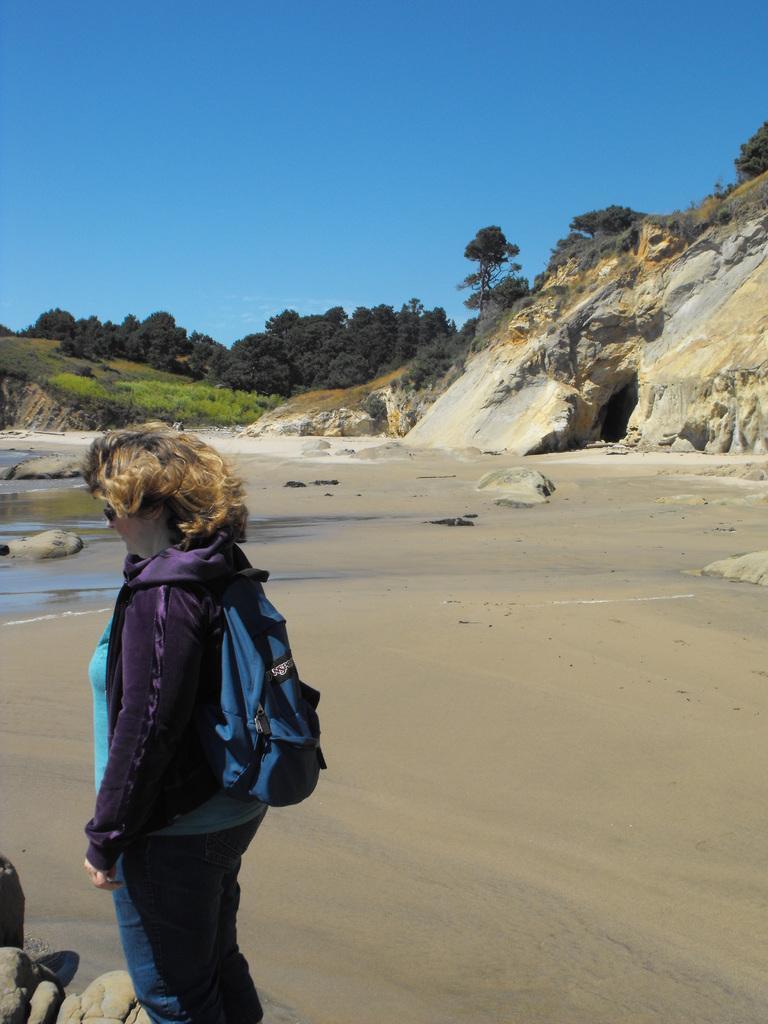In one or two sentences, can you explain what this image depicts? In the image there is a woman in the foreground, she is standing on the sand surface and in the background there are steep mountains and trees. 